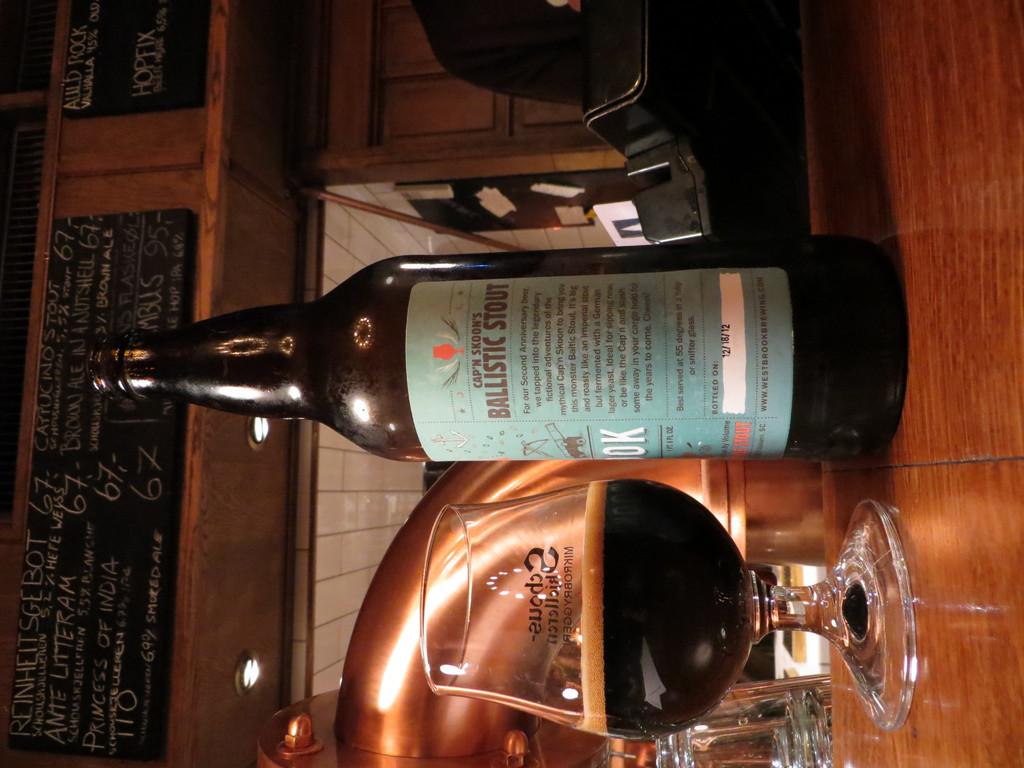What does the text say under the brand name?
Keep it short and to the point. Ballistic stout. 